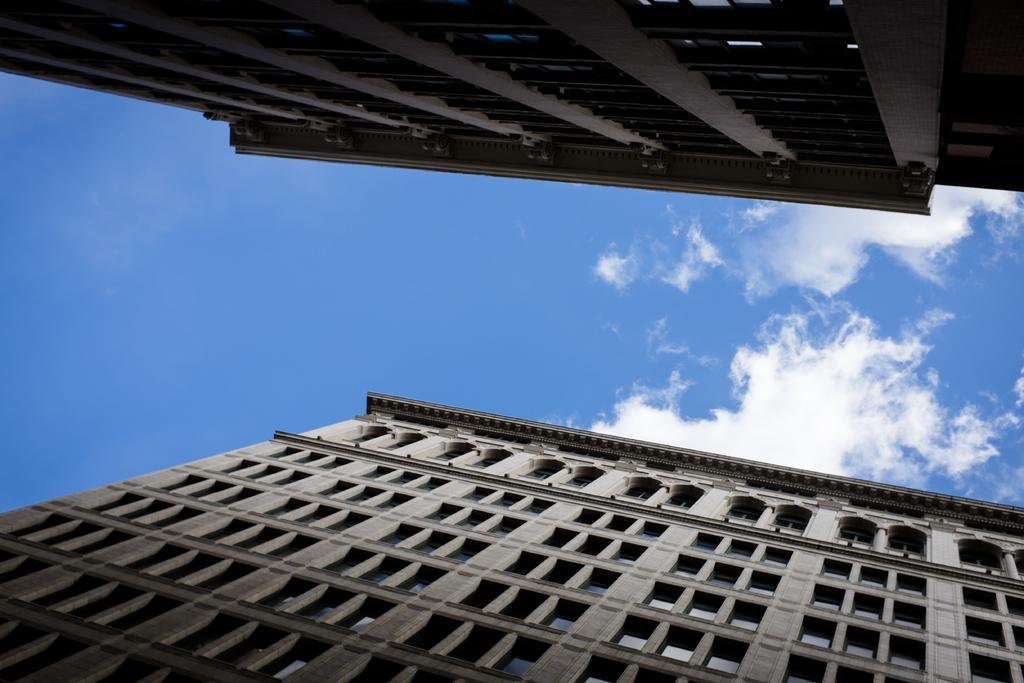What structures are present in the image? There are buildings in the image. What can be seen in the background of the image? There are clouds visible in the background of the image. What color is the sky in the background of the image? The sky is blue in the background of the image. Can you see any requests being made in the image? There is no indication of any requests being made in the image. What type of hook is visible in the image? There is no hook present in the image. 